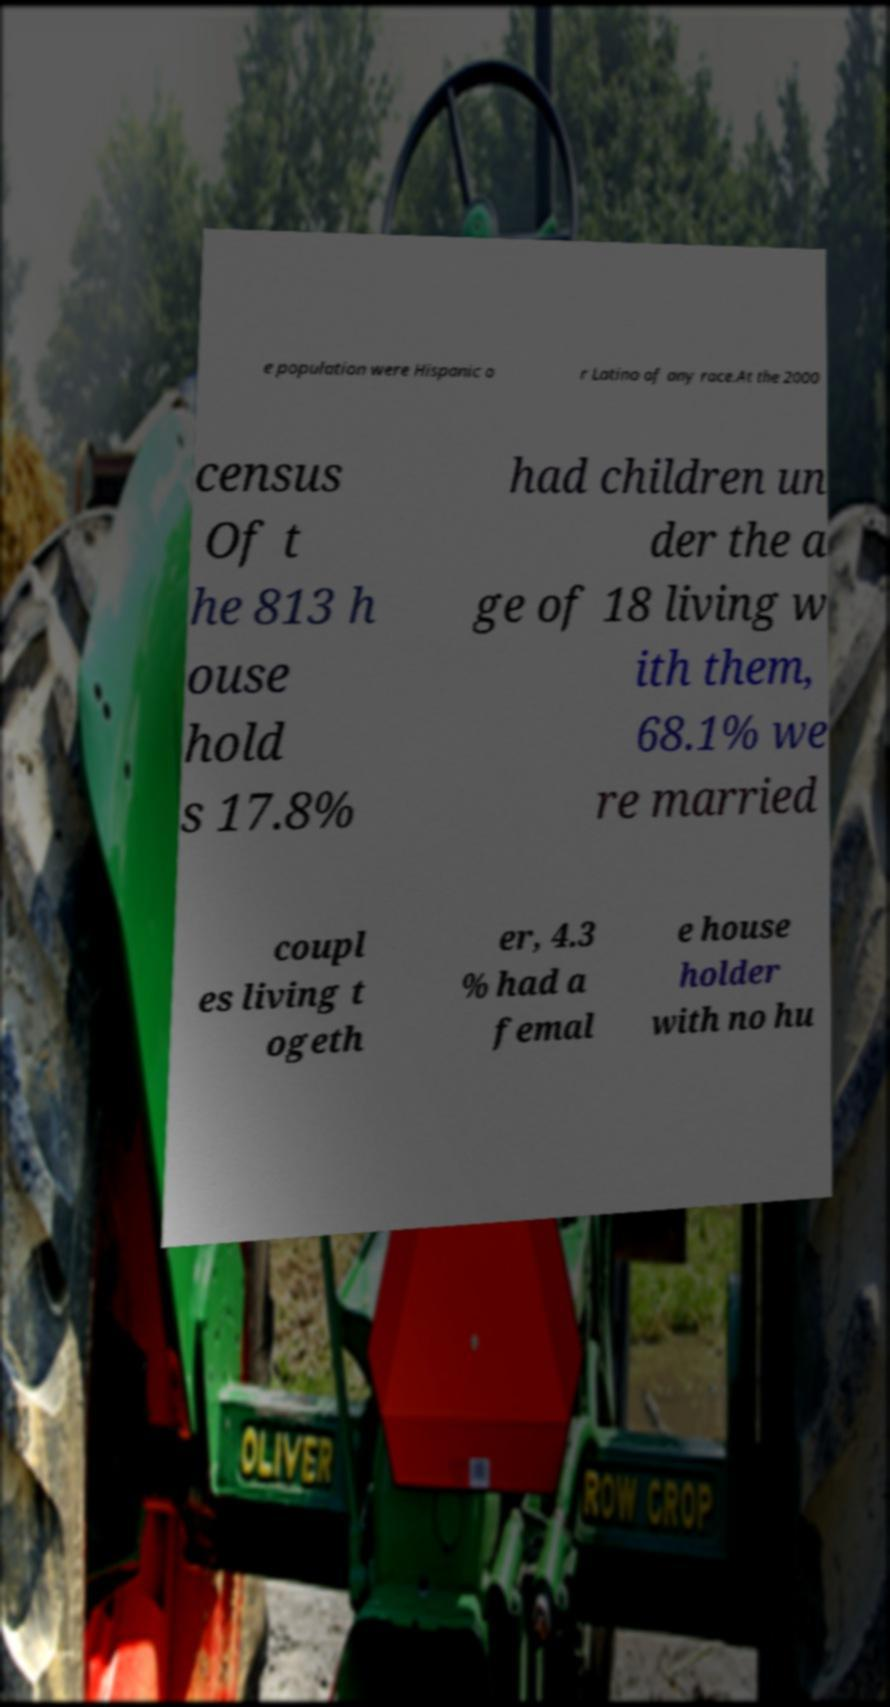Please identify and transcribe the text found in this image. e population were Hispanic o r Latino of any race.At the 2000 census Of t he 813 h ouse hold s 17.8% had children un der the a ge of 18 living w ith them, 68.1% we re married coupl es living t ogeth er, 4.3 % had a femal e house holder with no hu 